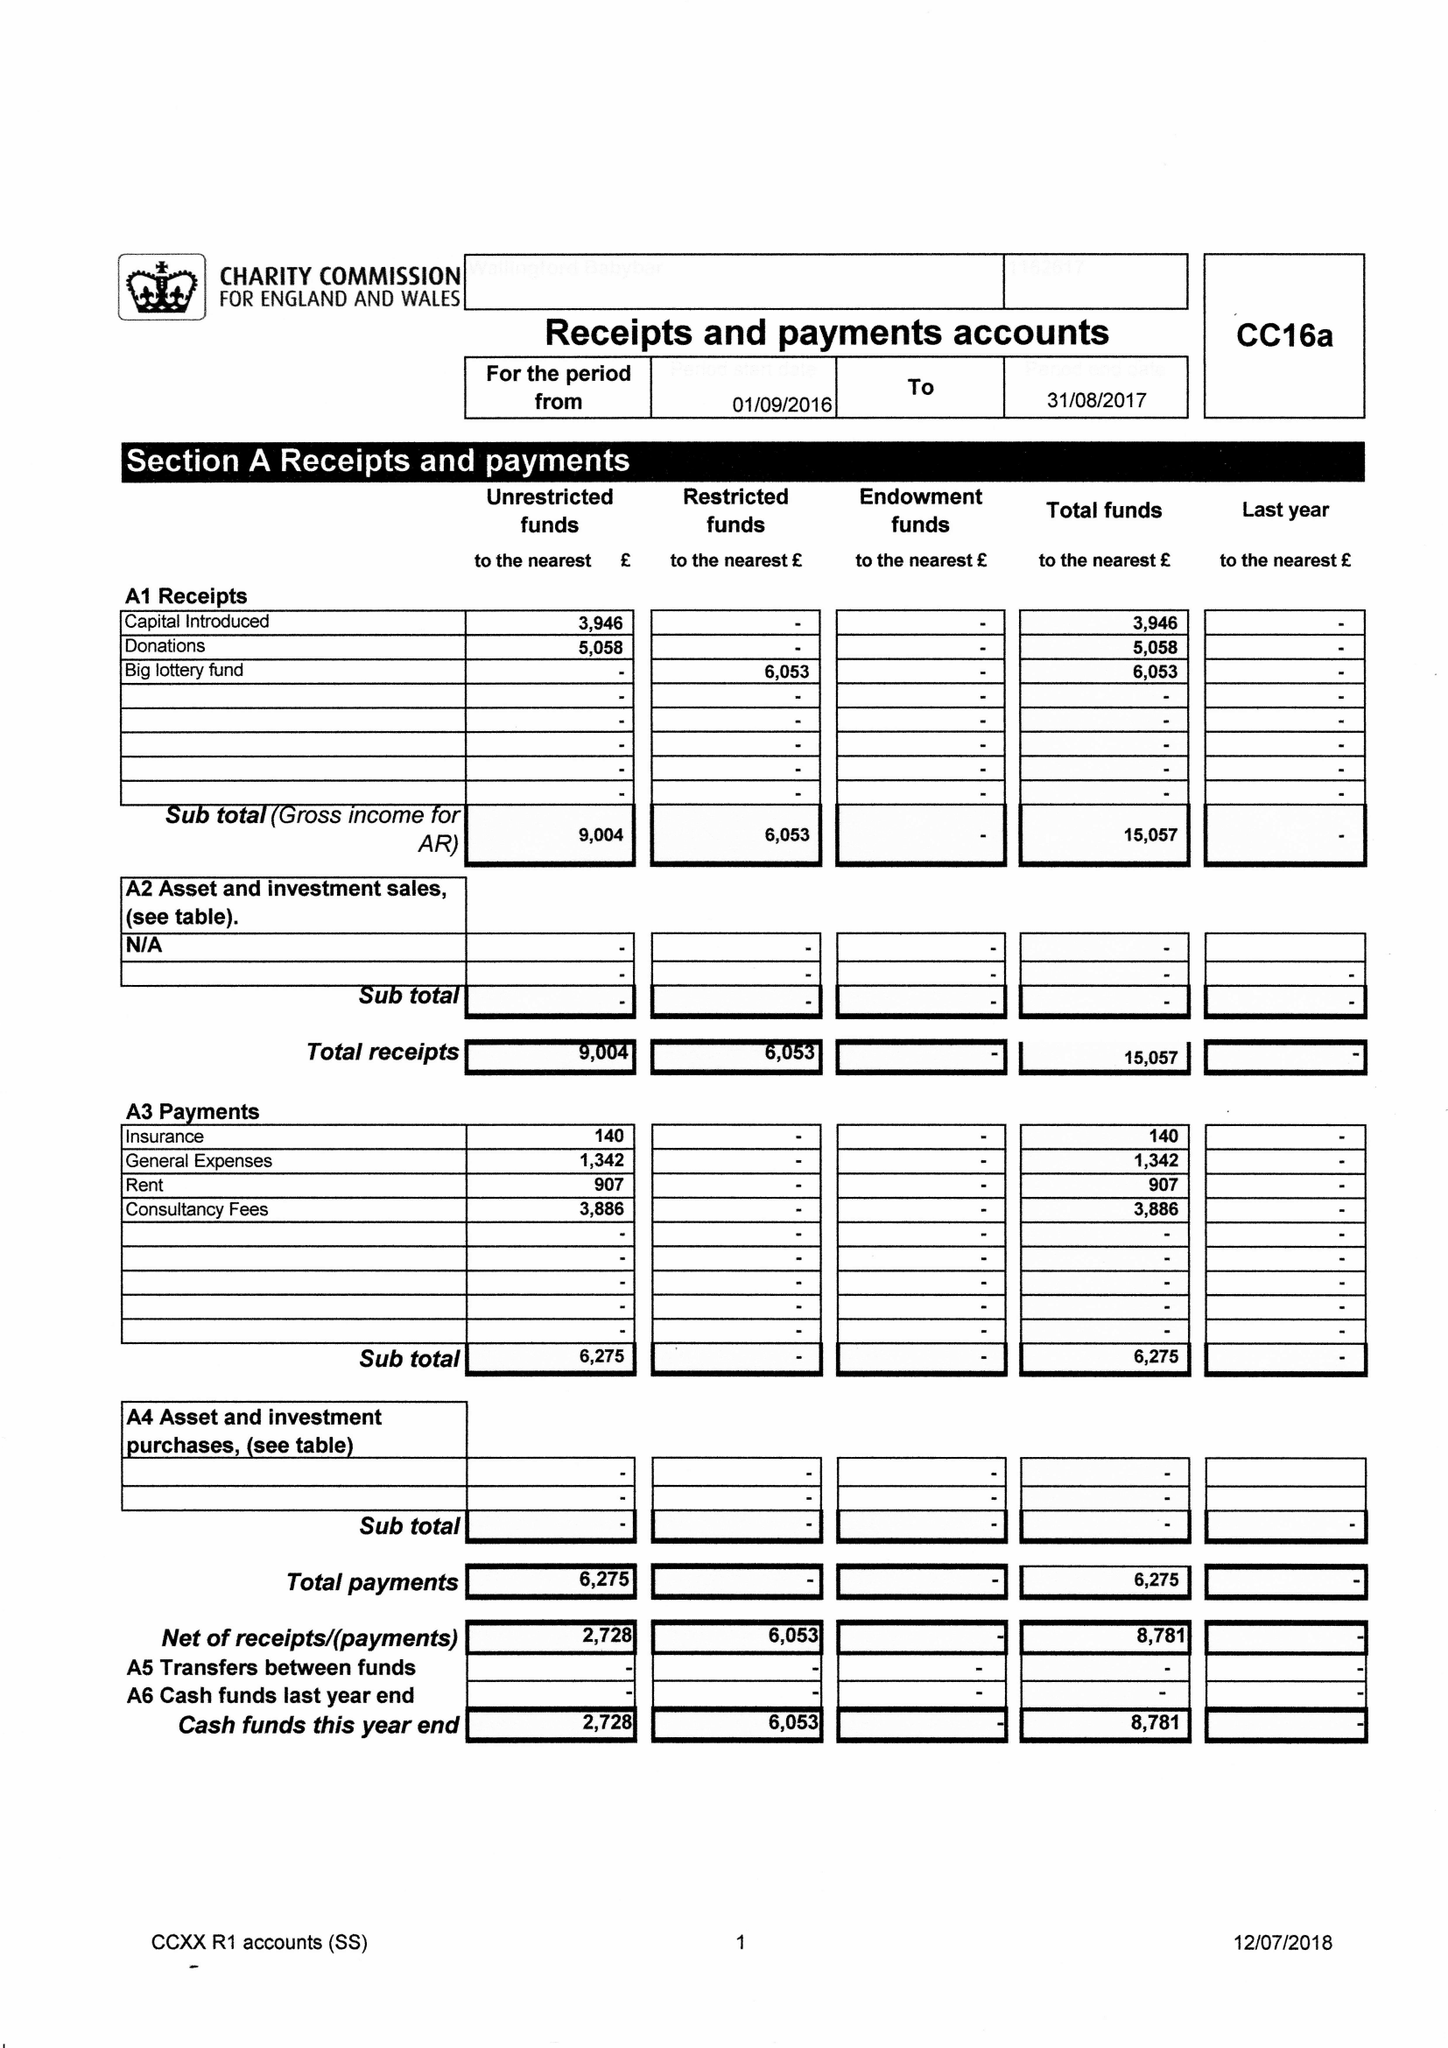What is the value for the address__postcode?
Answer the question using a single word or phrase. OX10 9GF 